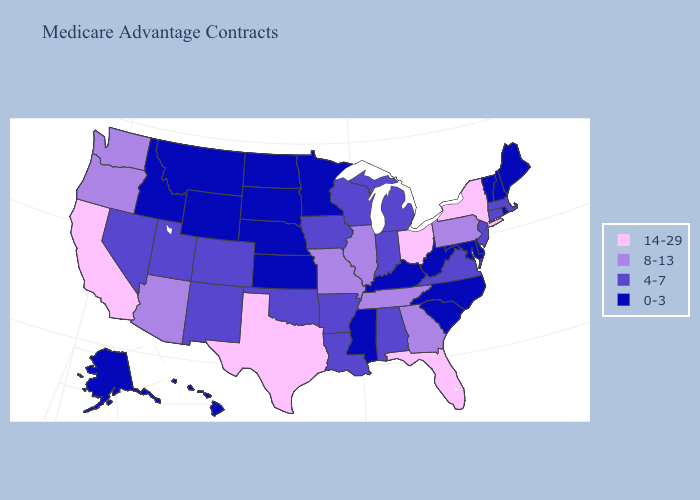What is the value of Nebraska?
Be succinct. 0-3. Name the states that have a value in the range 8-13?
Concise answer only. Arizona, Georgia, Illinois, Missouri, Oregon, Pennsylvania, Tennessee, Washington. What is the lowest value in the Northeast?
Quick response, please. 0-3. Among the states that border Ohio , does Kentucky have the highest value?
Give a very brief answer. No. What is the value of Minnesota?
Quick response, please. 0-3. Which states hav the highest value in the MidWest?
Give a very brief answer. Ohio. Name the states that have a value in the range 14-29?
Short answer required. California, Florida, New York, Ohio, Texas. Name the states that have a value in the range 8-13?
Be succinct. Arizona, Georgia, Illinois, Missouri, Oregon, Pennsylvania, Tennessee, Washington. Does Washington have the lowest value in the West?
Keep it brief. No. Does California have the lowest value in the West?
Give a very brief answer. No. What is the value of California?
Short answer required. 14-29. Which states have the highest value in the USA?
Short answer required. California, Florida, New York, Ohio, Texas. What is the highest value in the USA?
Be succinct. 14-29. Does Arkansas have the highest value in the South?
Quick response, please. No. What is the highest value in states that border Wisconsin?
Give a very brief answer. 8-13. 